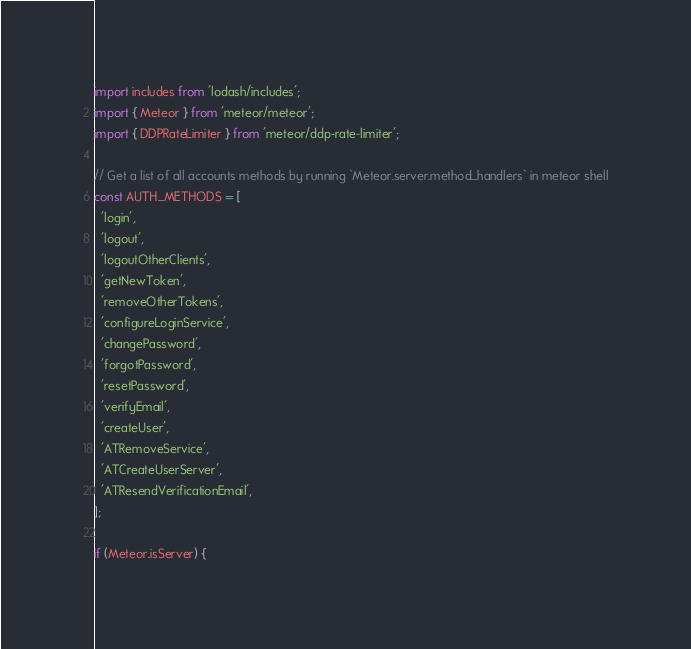Convert code to text. <code><loc_0><loc_0><loc_500><loc_500><_JavaScript_>import includes from 'lodash/includes';
import { Meteor } from 'meteor/meteor';
import { DDPRateLimiter } from 'meteor/ddp-rate-limiter';

// Get a list of all accounts methods by running `Meteor.server.method_handlers` in meteor shell
const AUTH_METHODS = [
  'login',
  'logout',
  'logoutOtherClients',
  'getNewToken',
  'removeOtherTokens',
  'configureLoginService',
  'changePassword',
  'forgotPassword',
  'resetPassword',
  'verifyEmail',
  'createUser',
  'ATRemoveService',
  'ATCreateUserServer',
  'ATResendVerificationEmail',
];

if (Meteor.isServer) {</code> 